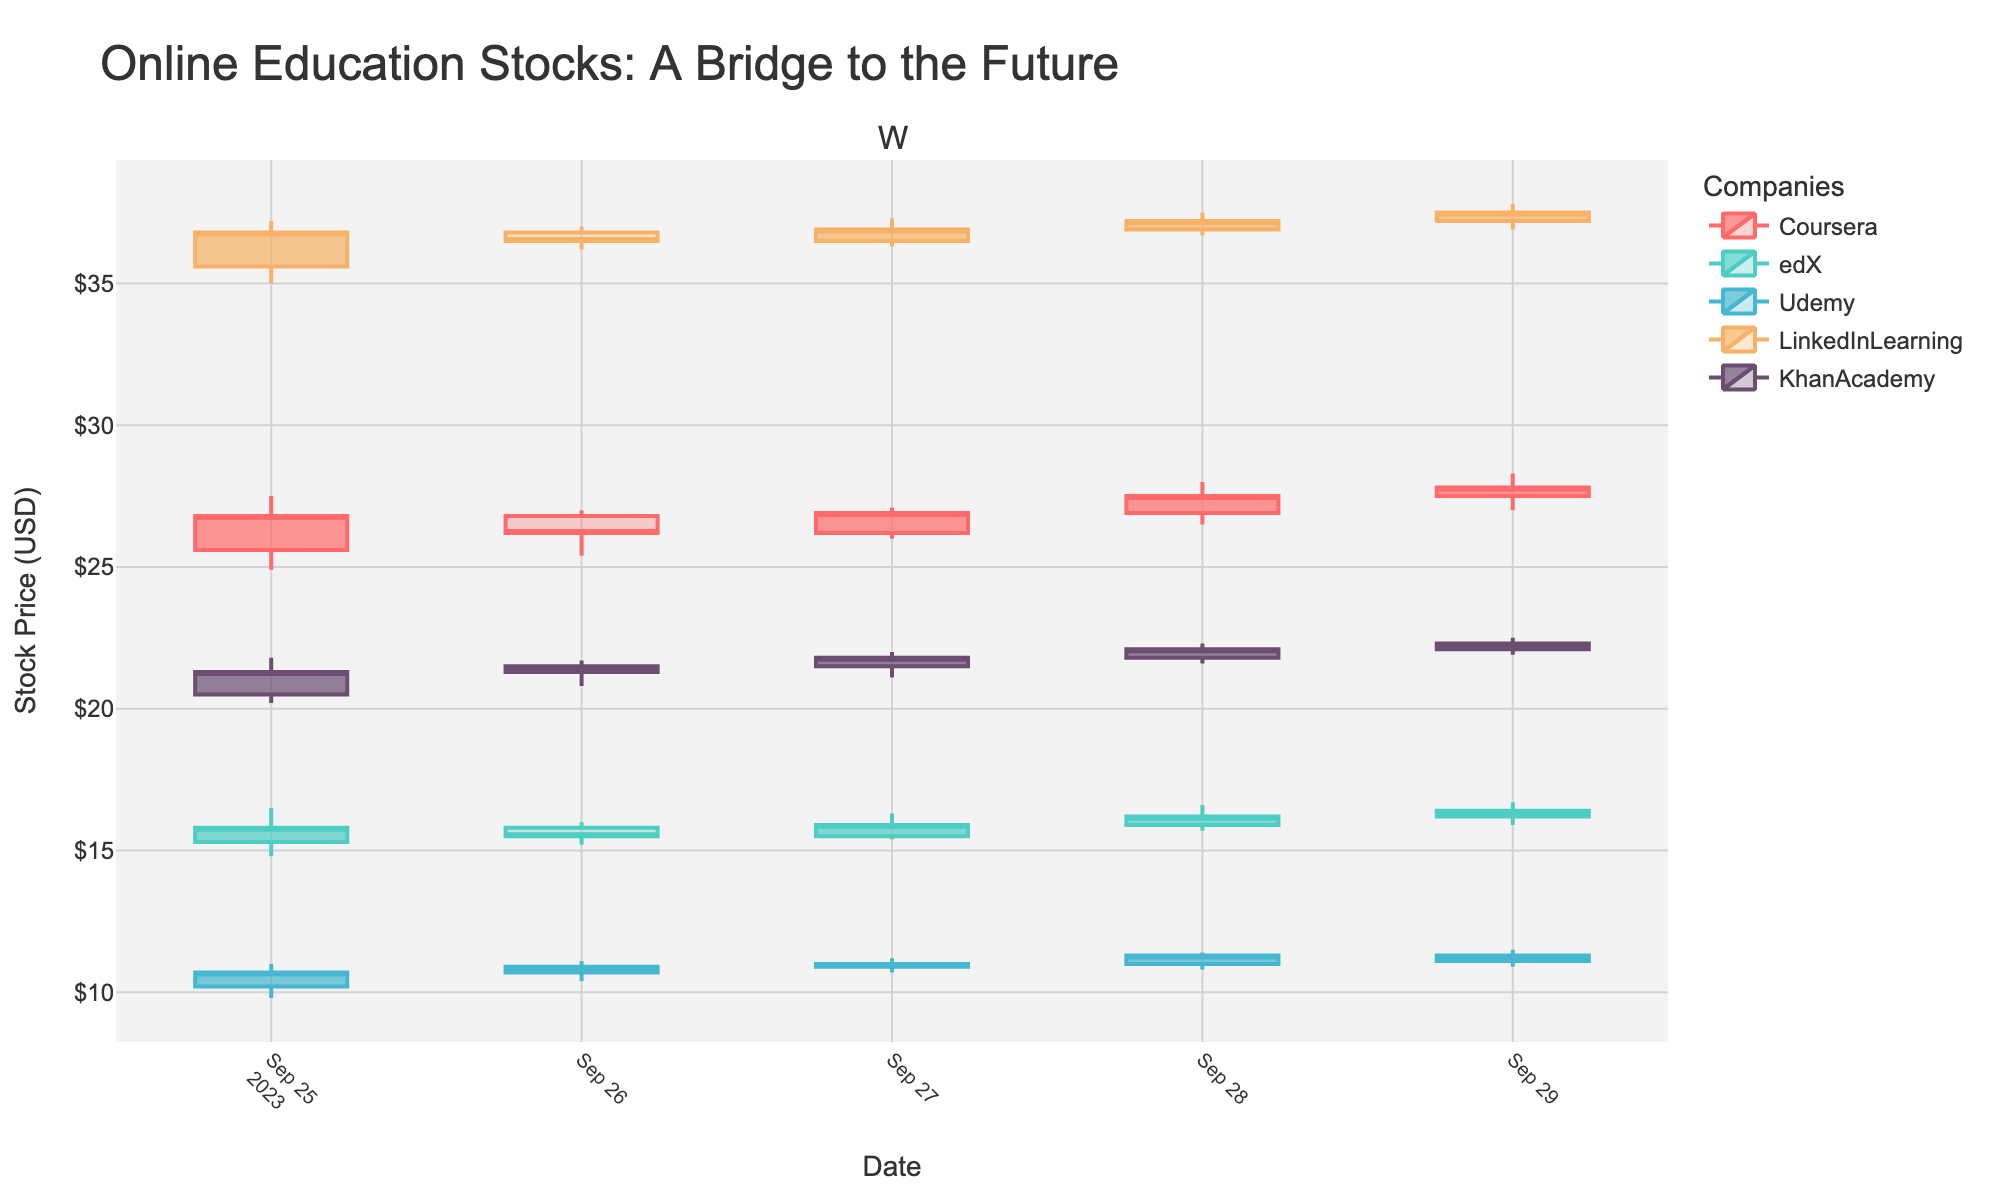What is the title of the plot? The title is displayed prominently at the top of the plot, reading "Online Education Stocks: A Bridge to the Future."
Answer: Online Education Stocks: A Bridge to the Future What is the stock price range for Coursera on September 27? The candlestick for Coursera on September 27 shows the highest price as 27.10 and the lowest price as 26.00.
Answer: 26.00 to 27.10 Which company had the highest closing price on September 29? To find the highest closing price on September 29, review the closing prices for all companies. LinkedInLearning had the highest closing price of 37.50.
Answer: LinkedInLearning with 37.50 Did edX's stock price increase, decrease, or remain stable from September 25 to September 29? Compare the opening price on September 25 (15.30) to the closing price on September 29 (16.40). Since 16.40 is higher than 15.30, the stock price increased.
Answer: Increased What is the color representing Udemy in the plot? The color for each company is uniquely specified, and for Udemy, it is light blue.
Answer: Light blue On which date did KhanAcademy have the largest range of stock prices, and what was the range? For each date, calculate the range by subtracting the low price from the high price for KhanAcademy. The largest range is on September 25, with a range of (21.80 - 20.20 = 1.60).
Answer: September 25, 1.60 Between LinkedInLearning and Coursera, which company's highest price was higher over the week? Compare the highest prices achieved by LinkedInLearning (37.80) and Coursera (28.30). LinkedInLearning had the higher highest price.
Answer: LinkedInLearning What trend can you observe in KhanAcademy's closing prices across the week? Examine the closing prices for KhanAcademy: 21.30, 21.50, 21.80, 22.10, 22.30. The trend shows a gradual increase each day.
Answer: Gradually increasing How many companies saw their stock price close higher on September 29 than their opening price on the same day? Compare the opening and closing prices on September 29 for each company: Coursera (27.50 vs 27.80), edX (16.20 vs 16.40), Udemy (11.30 vs 11.10), LinkedInLearning (37.20 vs 37.50), KhanAcademy (22.10 vs 22.30). Three companies (Coursera, edX, and LinkedInLearning) closed higher.
Answer: Three Which day of the week had the highest trading volume for LinkedInLearning? Review the trading volume for LinkedInLearning each day. The highest volume is on September 29, with 5,400,000 shares traded.
Answer: September 29 